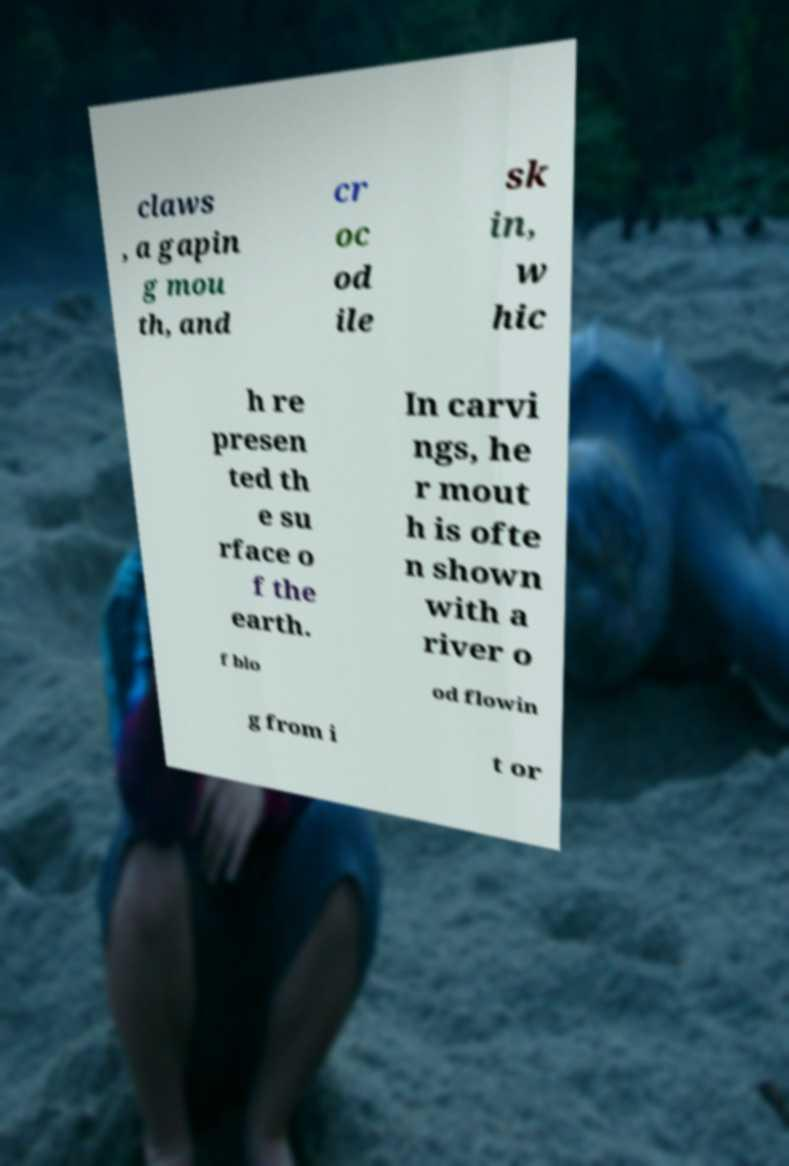Please read and relay the text visible in this image. What does it say? claws , a gapin g mou th, and cr oc od ile sk in, w hic h re presen ted th e su rface o f the earth. In carvi ngs, he r mout h is ofte n shown with a river o f blo od flowin g from i t or 